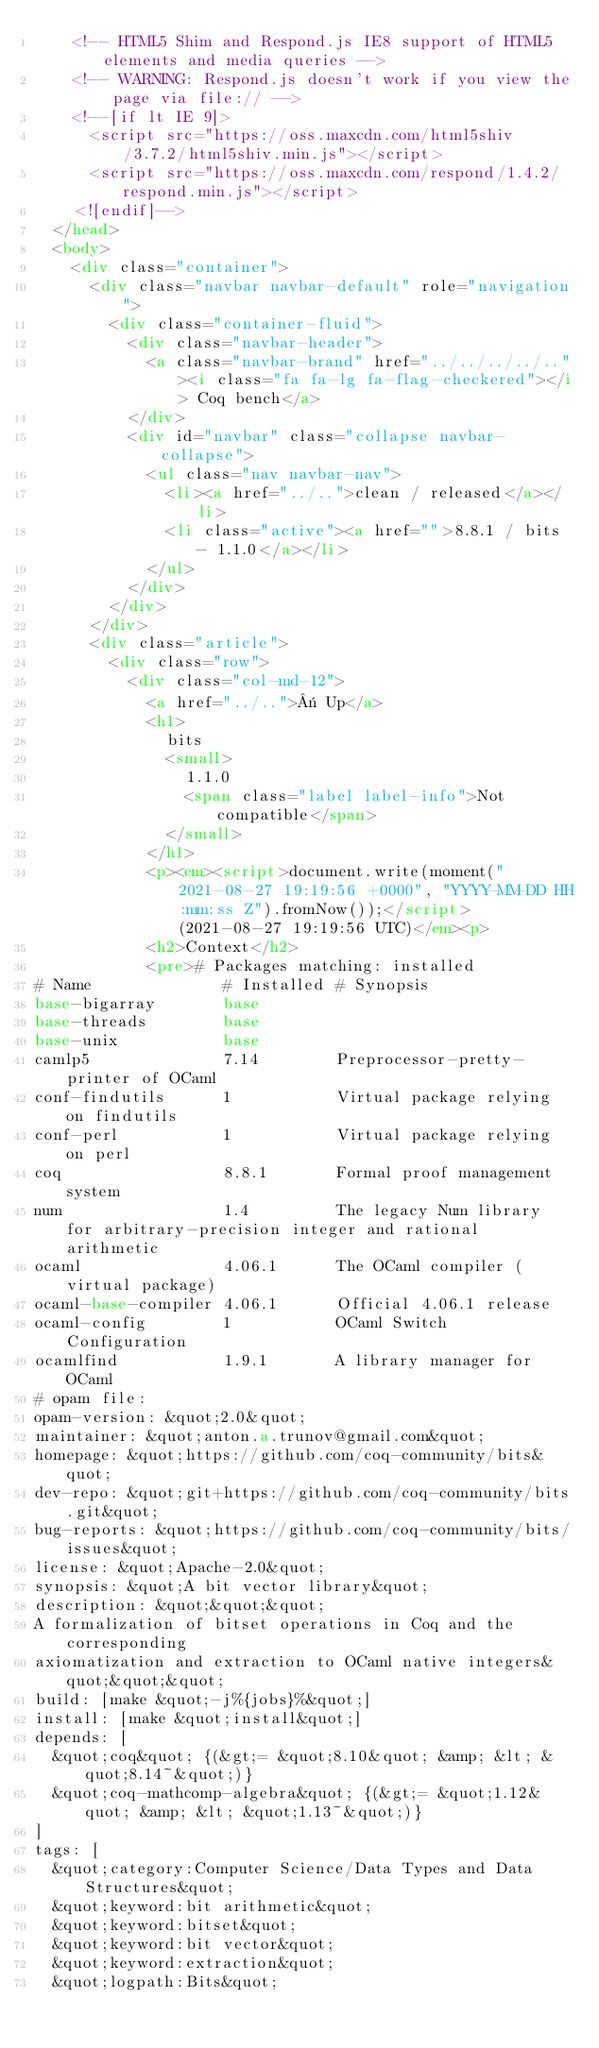Convert code to text. <code><loc_0><loc_0><loc_500><loc_500><_HTML_>    <!-- HTML5 Shim and Respond.js IE8 support of HTML5 elements and media queries -->
    <!-- WARNING: Respond.js doesn't work if you view the page via file:// -->
    <!--[if lt IE 9]>
      <script src="https://oss.maxcdn.com/html5shiv/3.7.2/html5shiv.min.js"></script>
      <script src="https://oss.maxcdn.com/respond/1.4.2/respond.min.js"></script>
    <![endif]-->
  </head>
  <body>
    <div class="container">
      <div class="navbar navbar-default" role="navigation">
        <div class="container-fluid">
          <div class="navbar-header">
            <a class="navbar-brand" href="../../../../.."><i class="fa fa-lg fa-flag-checkered"></i> Coq bench</a>
          </div>
          <div id="navbar" class="collapse navbar-collapse">
            <ul class="nav navbar-nav">
              <li><a href="../..">clean / released</a></li>
              <li class="active"><a href="">8.8.1 / bits - 1.1.0</a></li>
            </ul>
          </div>
        </div>
      </div>
      <div class="article">
        <div class="row">
          <div class="col-md-12">
            <a href="../..">« Up</a>
            <h1>
              bits
              <small>
                1.1.0
                <span class="label label-info">Not compatible</span>
              </small>
            </h1>
            <p><em><script>document.write(moment("2021-08-27 19:19:56 +0000", "YYYY-MM-DD HH:mm:ss Z").fromNow());</script> (2021-08-27 19:19:56 UTC)</em><p>
            <h2>Context</h2>
            <pre># Packages matching: installed
# Name              # Installed # Synopsis
base-bigarray       base
base-threads        base
base-unix           base
camlp5              7.14        Preprocessor-pretty-printer of OCaml
conf-findutils      1           Virtual package relying on findutils
conf-perl           1           Virtual package relying on perl
coq                 8.8.1       Formal proof management system
num                 1.4         The legacy Num library for arbitrary-precision integer and rational arithmetic
ocaml               4.06.1      The OCaml compiler (virtual package)
ocaml-base-compiler 4.06.1      Official 4.06.1 release
ocaml-config        1           OCaml Switch Configuration
ocamlfind           1.9.1       A library manager for OCaml
# opam file:
opam-version: &quot;2.0&quot;
maintainer: &quot;anton.a.trunov@gmail.com&quot;
homepage: &quot;https://github.com/coq-community/bits&quot;
dev-repo: &quot;git+https://github.com/coq-community/bits.git&quot;
bug-reports: &quot;https://github.com/coq-community/bits/issues&quot;
license: &quot;Apache-2.0&quot;
synopsis: &quot;A bit vector library&quot;
description: &quot;&quot;&quot;
A formalization of bitset operations in Coq and the corresponding
axiomatization and extraction to OCaml native integers&quot;&quot;&quot;
build: [make &quot;-j%{jobs}%&quot;]
install: [make &quot;install&quot;]
depends: [
  &quot;coq&quot; {(&gt;= &quot;8.10&quot; &amp; &lt; &quot;8.14~&quot;)}
  &quot;coq-mathcomp-algebra&quot; {(&gt;= &quot;1.12&quot; &amp; &lt; &quot;1.13~&quot;)}
]
tags: [
  &quot;category:Computer Science/Data Types and Data Structures&quot;
  &quot;keyword:bit arithmetic&quot;
  &quot;keyword:bitset&quot;
  &quot;keyword:bit vector&quot;
  &quot;keyword:extraction&quot;
  &quot;logpath:Bits&quot;</code> 